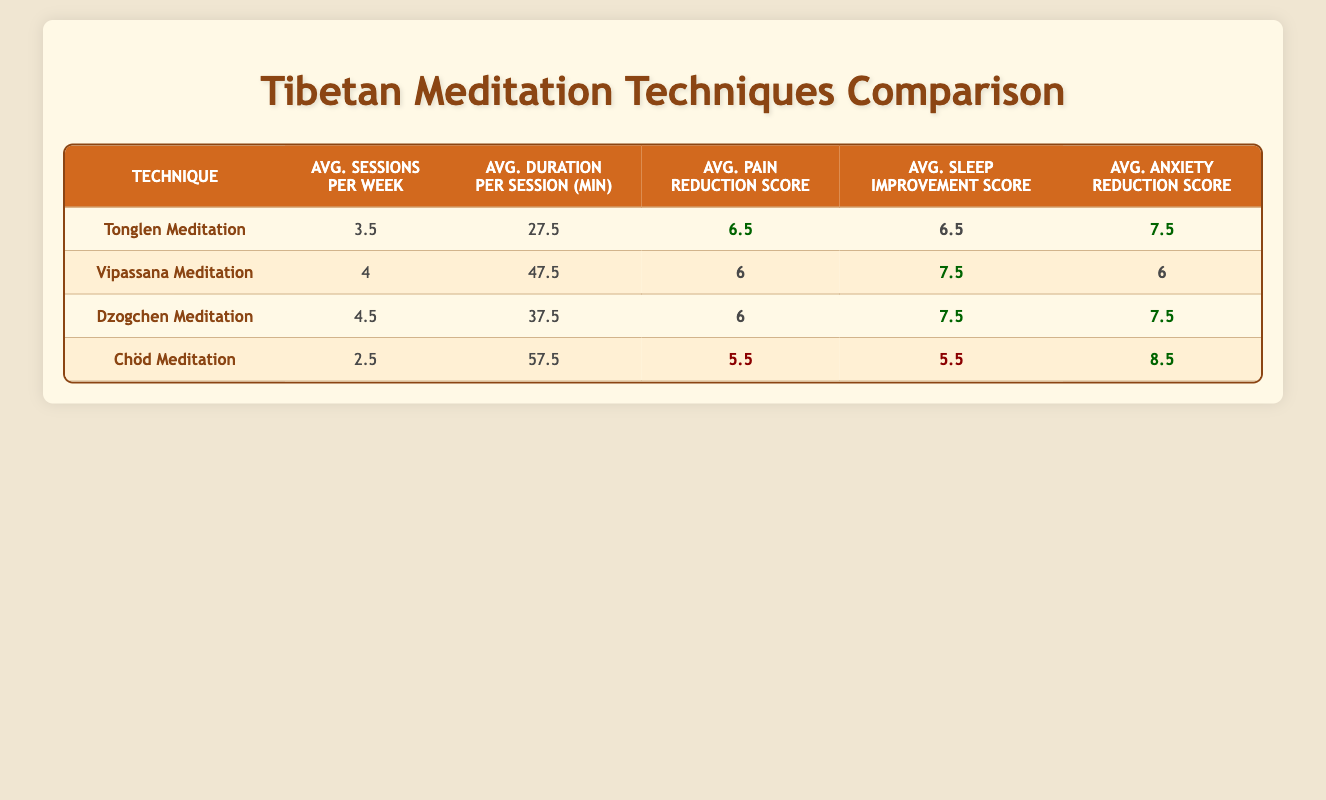What is the average pain reduction score for Chöd Meditation? The pain reduction score for Chöd Meditation is 5.5, as shown in the table. There is only one value for this technique.
Answer: 5.5 Which meditation technique has the highest average anxiety reduction score? Looking at the averages for anxiety reduction across the techniques, Chöd Meditation has the highest score of 8.5.
Answer: Chöd Meditation What is the average duration per session for Dzogchen Meditation? The average duration per session for Dzogchen Meditation is 37.5 minutes, as indicated in the table.
Answer: 37.5 Are the average sleep improvement scores for Vipassana and Dzogchen Meditation the same? The average sleep improvement score for Vipassana Meditation is 7.5, and for Dzogchen Meditation, it is also 7.5, which means they are indeed the same.
Answer: Yes What is the difference in average sessions per week between Tonglen and Chöd Meditation? The average sessions per week for Tonglen Meditation is 3.5, while for Chöd it is 2.5. The difference is 3.5 - 2.5 = 1.
Answer: 1 Which meditation technique offers the longest average session duration? Looking across the table, Chöd Meditation has the longest average session duration at 57.5 minutes.
Answer: Chöd Meditation What is the total of the pain reduction scores for all techniques listed? The pain reduction scores are: 6.5 (Tonglen) + 6 (Vipassana) + 6 (Dzogchen) + 5.5 (Chöd) = 24. The total score is 24.
Answer: 24 Is Dzogchen Meditation more effective in sleep improvement than both Chöd and Tonglen Meditation? Dzogchen has an average sleep improvement score of 7.5, while Chöd has 5.5 and Tonglen has 6.5. Hence, Dzogchen is indeed more effective than both.
Answer: Yes What is the average age of patients practicing the meditation technique with the highest pain reduction score? Tonglen Meditation has the highest average pain reduction score of 6.5. The ages of patients Tenzin Gyatso (62) and Karma Rinchen (70) average to (62 + 70) / 2 = 66.
Answer: 66 